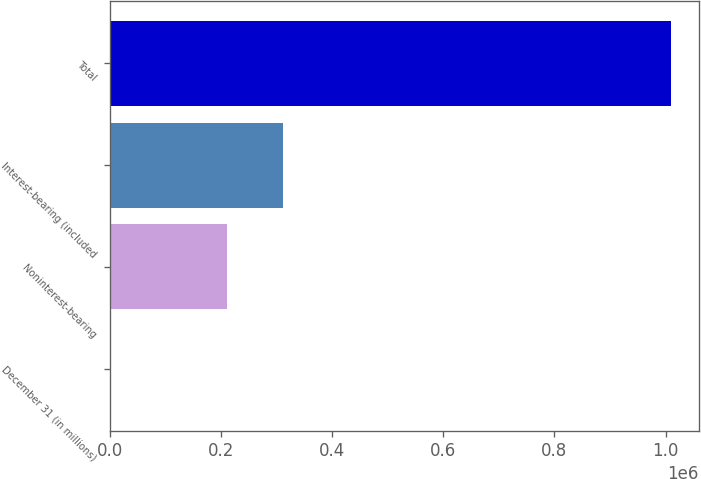Convert chart to OTSL. <chart><loc_0><loc_0><loc_500><loc_500><bar_chart><fcel>December 31 (in millions)<fcel>Noninterest-bearing<fcel>Interest-bearing (included<fcel>Total<nl><fcel>2008<fcel>210899<fcel>311626<fcel>1.00928e+06<nl></chart> 